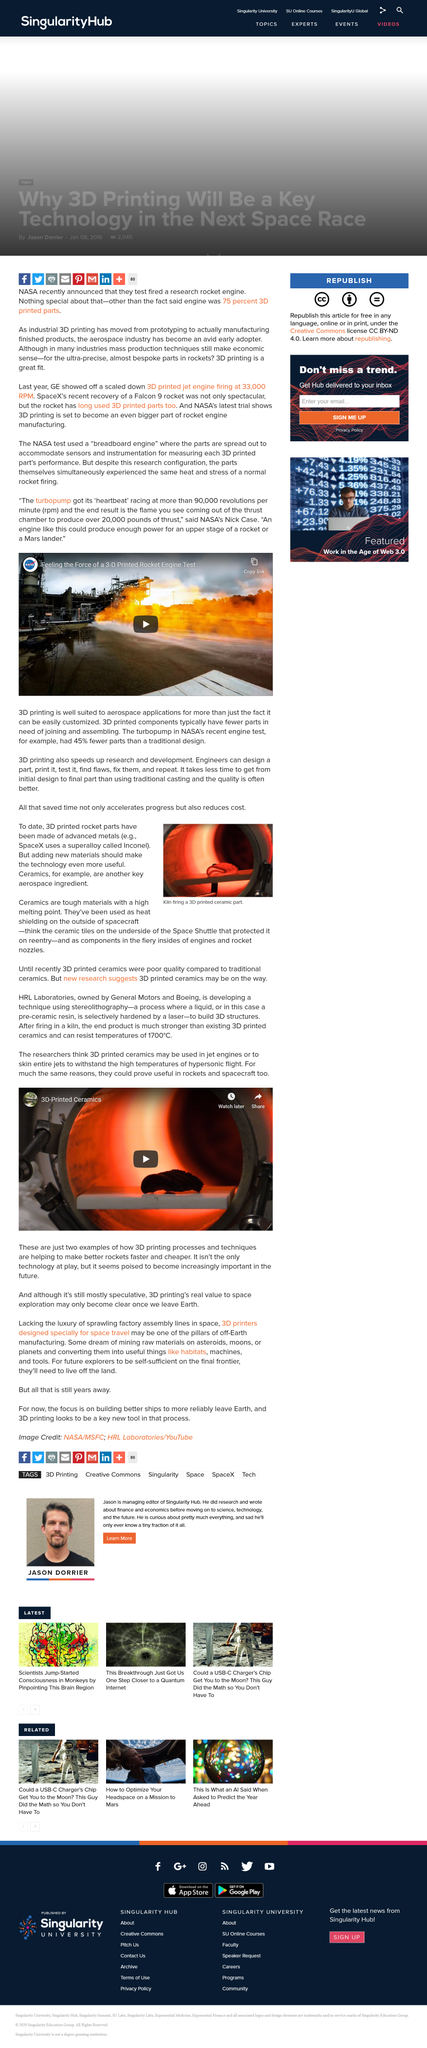Highlight a few significant elements in this photo. 3D printed ceramics have a wide range of applications, including in rockets and spacecraft. The underside of the Space Shuttle is made of ceramic tiles, which are highly resistant to heat and able to withstand the extreme temperatures and conditions encountered during re-entry into the Earth's atmosphere. 3D printing processes and techniques have the potential to significantly improve the efficiency and cost-effectiveness of rocket production. By utilizing these advanced technologies, we can create better rockets faster and more affordably, leading to safer, more reliable, and more efficient space travel. The recent engine test conducted by NASA featured a turbopump with 45% fewer parts than traditional designs, demonstrating a significant reduction in complexity and potential points of failure. The turbopump's 'heartbeat' races at more than 90,000 revolutions per minute. 